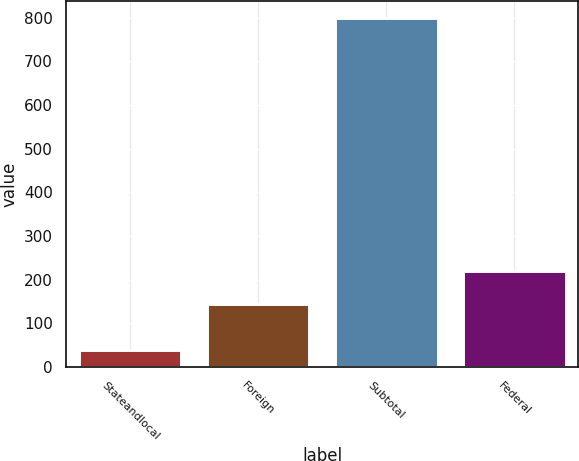Convert chart to OTSL. <chart><loc_0><loc_0><loc_500><loc_500><bar_chart><fcel>Stateandlocal<fcel>Foreign<fcel>Subtotal<fcel>Federal<nl><fcel>39<fcel>144<fcel>798<fcel>219.9<nl></chart> 